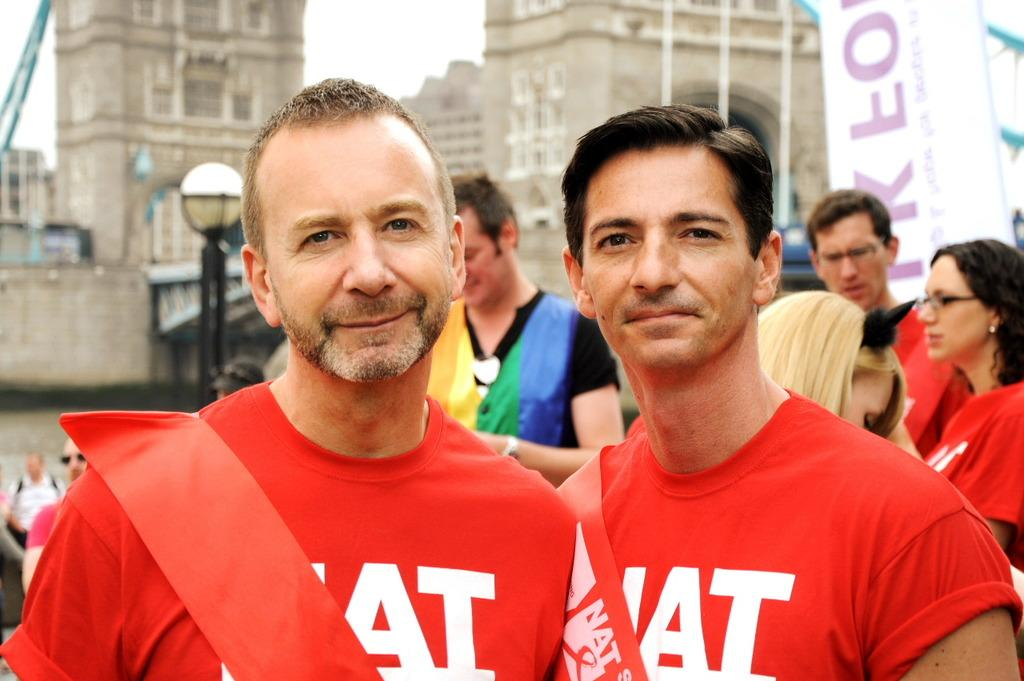How many people are in the image? There are two persons in the image. What are the people wearing? Both persons are wearing orange color t-shirts. What can be seen in the background of the image? There are buildings in the background of the image. What type of crown is the person wearing in the image? There is no crown present in the image; both persons are wearing orange color t-shirts. What musical instrument is the person playing in the image? There is no musical instrument present in the image; both persons are wearing orange color t-shirts. 